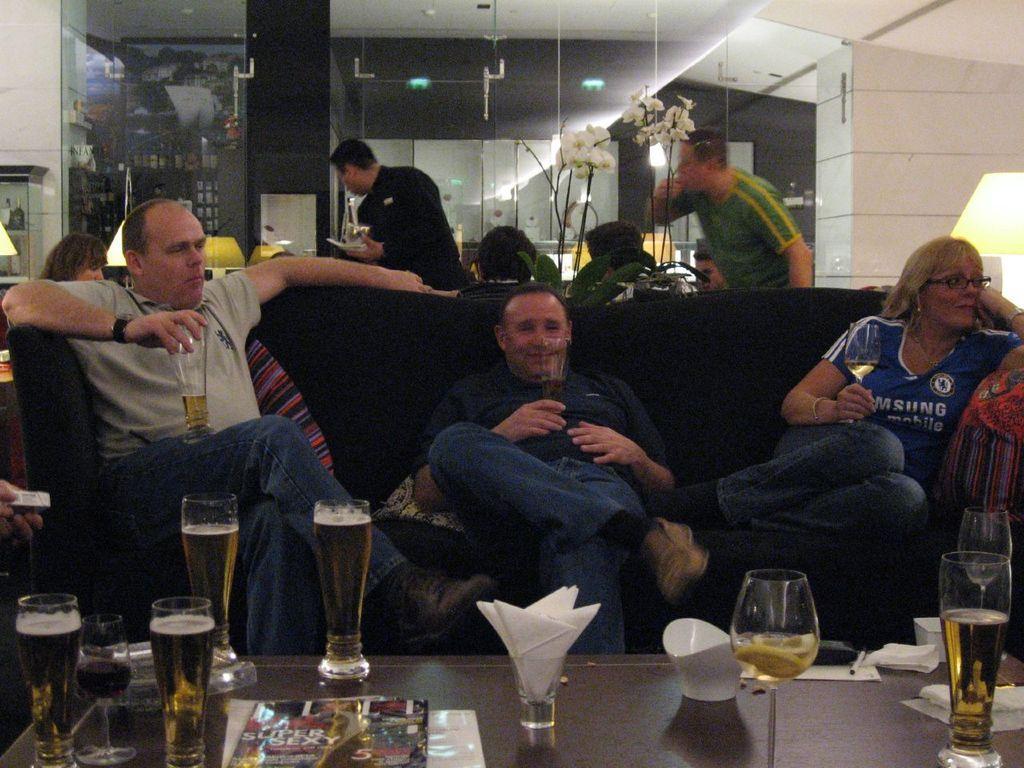Describe this image in one or two sentences. In this image we can see people sitting on the couch and holding beverage glasses in their hands and a table is placed in front of them. On the table we can see magazines, tissue holders, serving bowls, pen and beverage glasses. In the background we can see people sitting on the chairs and some are standing on the floor. 